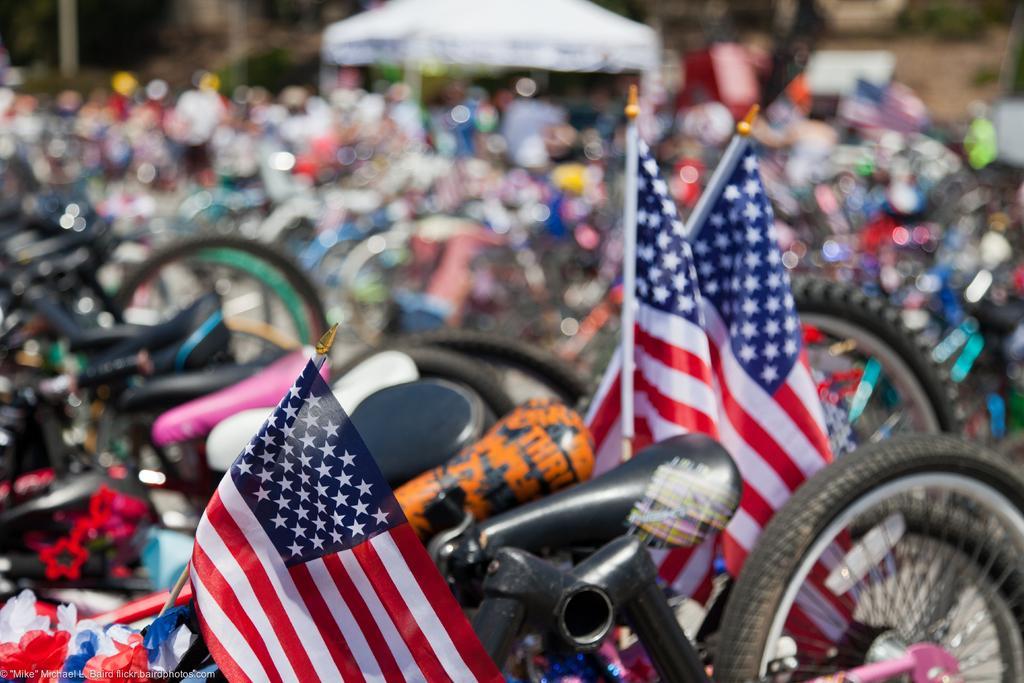Describe this image in one or two sentences. In this picture I see few cycles in front and I see 3 flags which are of white, red and blue in color and I see that it is blurred in the background and I see number of cycles and number of people. 